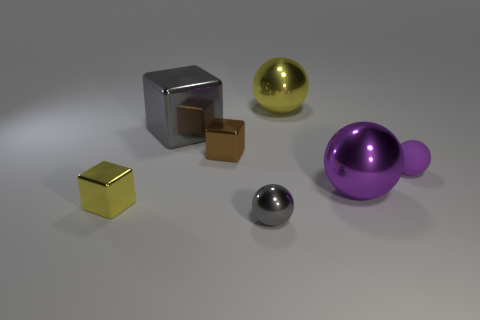What is the sphere that is in front of the brown block and behind the purple shiny ball made of? The sphere appears to have a metallic finish, suggesting that it could be made of a polished metal such as steel or aluminum. 